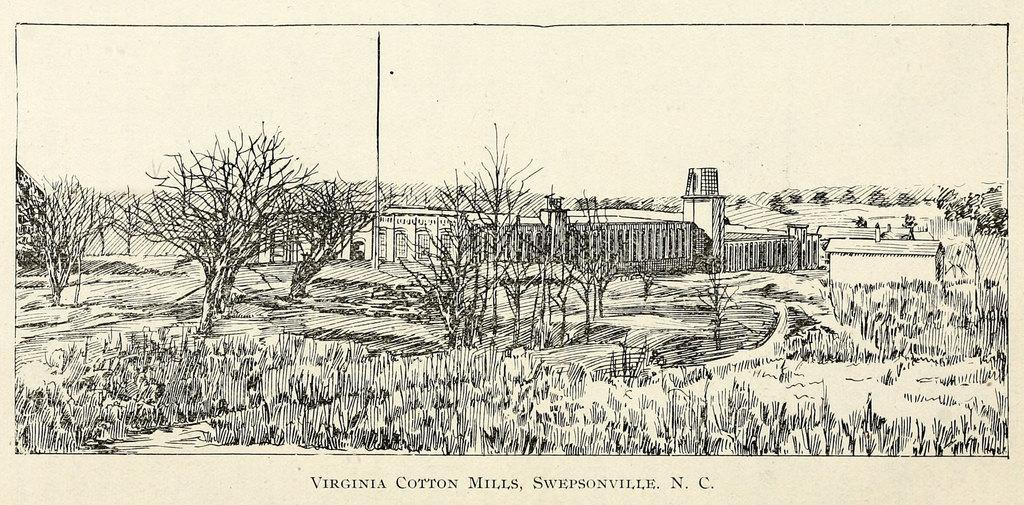What is present in the image that features a drawing? The image contains a poster with a drawing of a building. What elements are included in the drawing of the building? The drawing includes trees and grass. How many snails can be seen crawling on the grass in the image? There are no snails present in the image. 